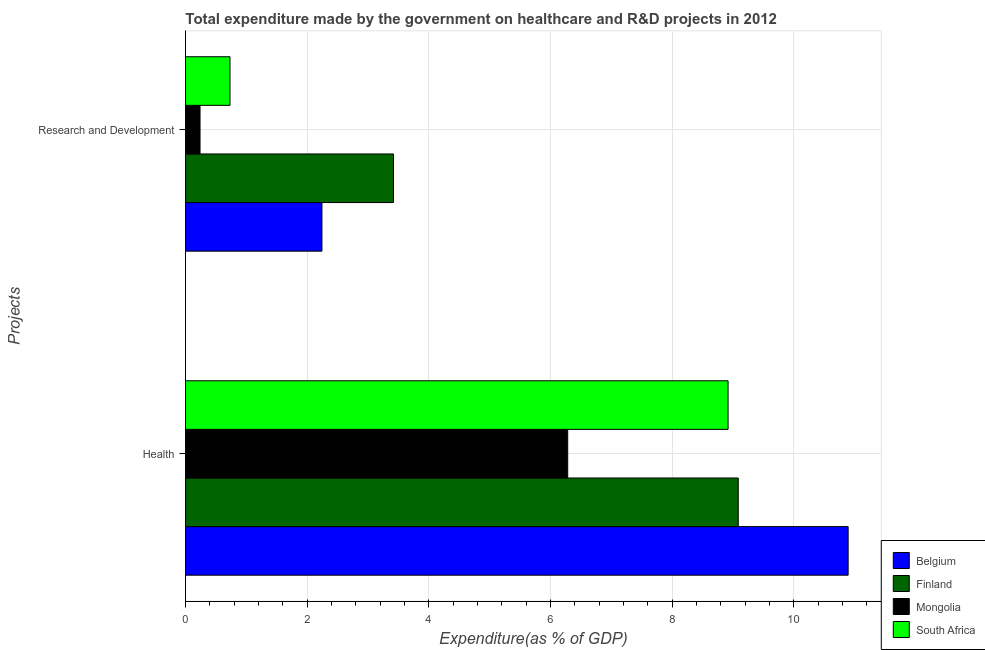How many different coloured bars are there?
Your answer should be compact. 4. Are the number of bars on each tick of the Y-axis equal?
Your response must be concise. Yes. What is the label of the 2nd group of bars from the top?
Your answer should be very brief. Health. What is the expenditure in healthcare in Finland?
Offer a terse response. 9.09. Across all countries, what is the maximum expenditure in r&d?
Offer a very short reply. 3.42. Across all countries, what is the minimum expenditure in r&d?
Offer a very short reply. 0.24. In which country was the expenditure in r&d maximum?
Provide a short and direct response. Finland. In which country was the expenditure in healthcare minimum?
Provide a succinct answer. Mongolia. What is the total expenditure in healthcare in the graph?
Offer a terse response. 35.19. What is the difference between the expenditure in r&d in Finland and that in Belgium?
Ensure brevity in your answer.  1.18. What is the difference between the expenditure in healthcare in Belgium and the expenditure in r&d in South Africa?
Your answer should be very brief. 10.16. What is the average expenditure in r&d per country?
Your answer should be compact. 1.66. What is the difference between the expenditure in healthcare and expenditure in r&d in Mongolia?
Provide a short and direct response. 6.04. What is the ratio of the expenditure in r&d in Finland to that in Mongolia?
Give a very brief answer. 14.3. Is the expenditure in r&d in South Africa less than that in Finland?
Offer a terse response. Yes. In how many countries, is the expenditure in r&d greater than the average expenditure in r&d taken over all countries?
Keep it short and to the point. 2. What does the 3rd bar from the bottom in Research and Development represents?
Ensure brevity in your answer.  Mongolia. How many bars are there?
Offer a terse response. 8. Are all the bars in the graph horizontal?
Make the answer very short. Yes. How many countries are there in the graph?
Provide a short and direct response. 4. What is the difference between two consecutive major ticks on the X-axis?
Give a very brief answer. 2. Where does the legend appear in the graph?
Your answer should be very brief. Bottom right. What is the title of the graph?
Ensure brevity in your answer.  Total expenditure made by the government on healthcare and R&D projects in 2012. What is the label or title of the X-axis?
Ensure brevity in your answer.  Expenditure(as % of GDP). What is the label or title of the Y-axis?
Give a very brief answer. Projects. What is the Expenditure(as % of GDP) in Belgium in Health?
Provide a short and direct response. 10.89. What is the Expenditure(as % of GDP) in Finland in Health?
Your response must be concise. 9.09. What is the Expenditure(as % of GDP) in Mongolia in Health?
Ensure brevity in your answer.  6.28. What is the Expenditure(as % of GDP) of South Africa in Health?
Your answer should be very brief. 8.92. What is the Expenditure(as % of GDP) of Belgium in Research and Development?
Make the answer very short. 2.24. What is the Expenditure(as % of GDP) in Finland in Research and Development?
Offer a terse response. 3.42. What is the Expenditure(as % of GDP) of Mongolia in Research and Development?
Keep it short and to the point. 0.24. What is the Expenditure(as % of GDP) of South Africa in Research and Development?
Keep it short and to the point. 0.73. Across all Projects, what is the maximum Expenditure(as % of GDP) of Belgium?
Your answer should be very brief. 10.89. Across all Projects, what is the maximum Expenditure(as % of GDP) in Finland?
Your answer should be very brief. 9.09. Across all Projects, what is the maximum Expenditure(as % of GDP) of Mongolia?
Ensure brevity in your answer.  6.28. Across all Projects, what is the maximum Expenditure(as % of GDP) of South Africa?
Give a very brief answer. 8.92. Across all Projects, what is the minimum Expenditure(as % of GDP) in Belgium?
Make the answer very short. 2.24. Across all Projects, what is the minimum Expenditure(as % of GDP) in Finland?
Offer a terse response. 3.42. Across all Projects, what is the minimum Expenditure(as % of GDP) in Mongolia?
Offer a very short reply. 0.24. Across all Projects, what is the minimum Expenditure(as % of GDP) in South Africa?
Offer a terse response. 0.73. What is the total Expenditure(as % of GDP) in Belgium in the graph?
Your answer should be compact. 13.14. What is the total Expenditure(as % of GDP) in Finland in the graph?
Offer a very short reply. 12.51. What is the total Expenditure(as % of GDP) of Mongolia in the graph?
Your response must be concise. 6.52. What is the total Expenditure(as % of GDP) in South Africa in the graph?
Offer a terse response. 9.65. What is the difference between the Expenditure(as % of GDP) of Belgium in Health and that in Research and Development?
Your answer should be compact. 8.65. What is the difference between the Expenditure(as % of GDP) in Finland in Health and that in Research and Development?
Offer a terse response. 5.67. What is the difference between the Expenditure(as % of GDP) in Mongolia in Health and that in Research and Development?
Your response must be concise. 6.04. What is the difference between the Expenditure(as % of GDP) of South Africa in Health and that in Research and Development?
Your answer should be compact. 8.19. What is the difference between the Expenditure(as % of GDP) in Belgium in Health and the Expenditure(as % of GDP) in Finland in Research and Development?
Provide a succinct answer. 7.47. What is the difference between the Expenditure(as % of GDP) of Belgium in Health and the Expenditure(as % of GDP) of Mongolia in Research and Development?
Give a very brief answer. 10.66. What is the difference between the Expenditure(as % of GDP) of Belgium in Health and the Expenditure(as % of GDP) of South Africa in Research and Development?
Offer a terse response. 10.16. What is the difference between the Expenditure(as % of GDP) in Finland in Health and the Expenditure(as % of GDP) in Mongolia in Research and Development?
Make the answer very short. 8.85. What is the difference between the Expenditure(as % of GDP) in Finland in Health and the Expenditure(as % of GDP) in South Africa in Research and Development?
Offer a terse response. 8.36. What is the difference between the Expenditure(as % of GDP) in Mongolia in Health and the Expenditure(as % of GDP) in South Africa in Research and Development?
Give a very brief answer. 5.55. What is the average Expenditure(as % of GDP) in Belgium per Projects?
Your response must be concise. 6.57. What is the average Expenditure(as % of GDP) in Finland per Projects?
Offer a very short reply. 6.25. What is the average Expenditure(as % of GDP) in Mongolia per Projects?
Make the answer very short. 3.26. What is the average Expenditure(as % of GDP) of South Africa per Projects?
Ensure brevity in your answer.  4.83. What is the difference between the Expenditure(as % of GDP) in Belgium and Expenditure(as % of GDP) in Finland in Health?
Your answer should be very brief. 1.81. What is the difference between the Expenditure(as % of GDP) of Belgium and Expenditure(as % of GDP) of Mongolia in Health?
Provide a succinct answer. 4.61. What is the difference between the Expenditure(as % of GDP) of Belgium and Expenditure(as % of GDP) of South Africa in Health?
Offer a terse response. 1.97. What is the difference between the Expenditure(as % of GDP) of Finland and Expenditure(as % of GDP) of Mongolia in Health?
Offer a very short reply. 2.8. What is the difference between the Expenditure(as % of GDP) of Finland and Expenditure(as % of GDP) of South Africa in Health?
Offer a very short reply. 0.17. What is the difference between the Expenditure(as % of GDP) of Mongolia and Expenditure(as % of GDP) of South Africa in Health?
Your answer should be compact. -2.64. What is the difference between the Expenditure(as % of GDP) of Belgium and Expenditure(as % of GDP) of Finland in Research and Development?
Provide a succinct answer. -1.18. What is the difference between the Expenditure(as % of GDP) in Belgium and Expenditure(as % of GDP) in Mongolia in Research and Development?
Your answer should be very brief. 2. What is the difference between the Expenditure(as % of GDP) in Belgium and Expenditure(as % of GDP) in South Africa in Research and Development?
Provide a short and direct response. 1.51. What is the difference between the Expenditure(as % of GDP) in Finland and Expenditure(as % of GDP) in Mongolia in Research and Development?
Your answer should be compact. 3.18. What is the difference between the Expenditure(as % of GDP) of Finland and Expenditure(as % of GDP) of South Africa in Research and Development?
Your response must be concise. 2.69. What is the difference between the Expenditure(as % of GDP) of Mongolia and Expenditure(as % of GDP) of South Africa in Research and Development?
Provide a short and direct response. -0.49. What is the ratio of the Expenditure(as % of GDP) of Belgium in Health to that in Research and Development?
Your response must be concise. 4.86. What is the ratio of the Expenditure(as % of GDP) of Finland in Health to that in Research and Development?
Make the answer very short. 2.66. What is the ratio of the Expenditure(as % of GDP) of Mongolia in Health to that in Research and Development?
Your response must be concise. 26.28. What is the ratio of the Expenditure(as % of GDP) in South Africa in Health to that in Research and Development?
Your answer should be compact. 12.19. What is the difference between the highest and the second highest Expenditure(as % of GDP) of Belgium?
Your answer should be compact. 8.65. What is the difference between the highest and the second highest Expenditure(as % of GDP) of Finland?
Your response must be concise. 5.67. What is the difference between the highest and the second highest Expenditure(as % of GDP) in Mongolia?
Your answer should be compact. 6.04. What is the difference between the highest and the second highest Expenditure(as % of GDP) in South Africa?
Give a very brief answer. 8.19. What is the difference between the highest and the lowest Expenditure(as % of GDP) in Belgium?
Give a very brief answer. 8.65. What is the difference between the highest and the lowest Expenditure(as % of GDP) of Finland?
Offer a terse response. 5.67. What is the difference between the highest and the lowest Expenditure(as % of GDP) in Mongolia?
Keep it short and to the point. 6.04. What is the difference between the highest and the lowest Expenditure(as % of GDP) in South Africa?
Your answer should be compact. 8.19. 